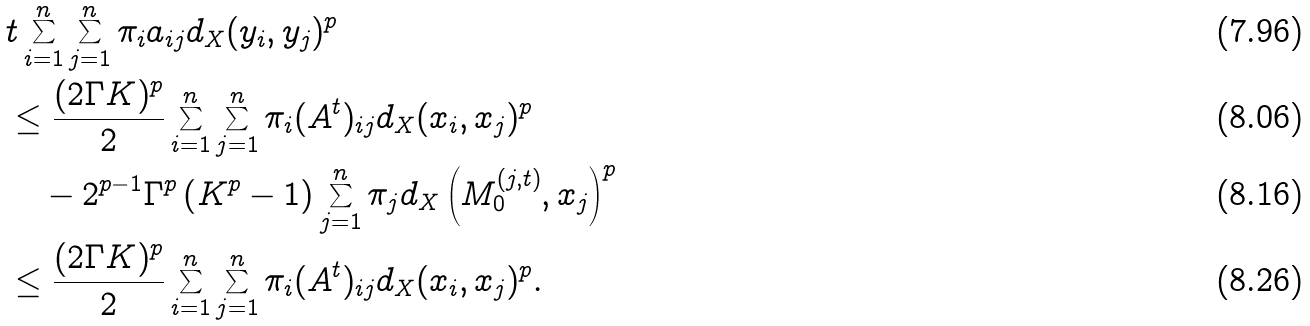Convert formula to latex. <formula><loc_0><loc_0><loc_500><loc_500>& t \sum _ { i = 1 } ^ { n } \sum _ { j = 1 } ^ { n } \pi _ { i } a _ { i j } d _ { X } ( y _ { i } , y _ { j } ) ^ { p } \\ & \leq \frac { ( 2 \Gamma K ) ^ { p } } { 2 } \sum _ { i = 1 } ^ { n } \sum _ { j = 1 } ^ { n } \pi _ { i } ( A ^ { t } ) _ { i j } d _ { X } ( x _ { i } , x _ { j } ) ^ { p } \\ & \quad - 2 ^ { p - 1 } \Gamma ^ { p } \left ( K ^ { p } - 1 \right ) \sum _ { j = 1 } ^ { n } \pi _ { j } d _ { X } \left ( M _ { 0 } ^ { ( j , t ) } , x _ { j } \right ) ^ { p } \\ & \leq \frac { ( 2 \Gamma K ) ^ { p } } { 2 } \sum _ { i = 1 } ^ { n } \sum _ { j = 1 } ^ { n } \pi _ { i } ( A ^ { t } ) _ { i j } d _ { X } ( x _ { i } , x _ { j } ) ^ { p } .</formula> 